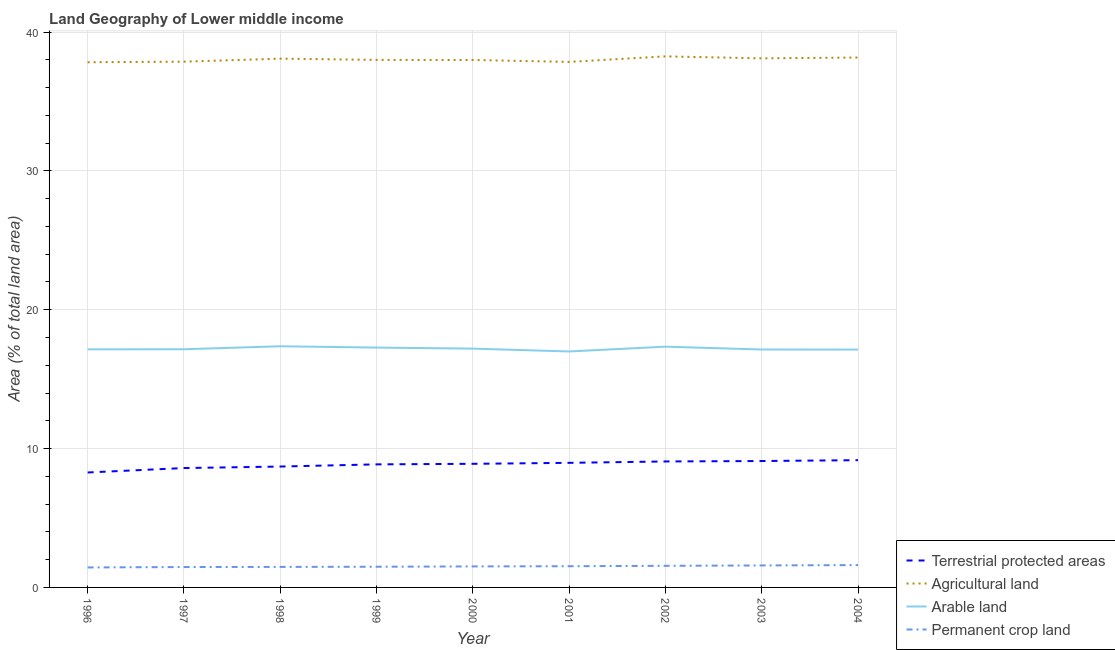Does the line corresponding to percentage of land under terrestrial protection intersect with the line corresponding to percentage of area under agricultural land?
Your response must be concise. No. What is the percentage of area under arable land in 1997?
Give a very brief answer. 17.15. Across all years, what is the maximum percentage of area under arable land?
Your answer should be compact. 17.37. Across all years, what is the minimum percentage of area under arable land?
Offer a terse response. 16.99. In which year was the percentage of area under agricultural land minimum?
Ensure brevity in your answer.  1996. What is the total percentage of land under terrestrial protection in the graph?
Make the answer very short. 79.66. What is the difference between the percentage of area under agricultural land in 1998 and that in 2004?
Ensure brevity in your answer.  -0.08. What is the difference between the percentage of area under arable land in 2001 and the percentage of land under terrestrial protection in 1996?
Offer a very short reply. 8.71. What is the average percentage of area under permanent crop land per year?
Give a very brief answer. 1.52. In the year 1996, what is the difference between the percentage of area under agricultural land and percentage of area under arable land?
Your answer should be compact. 20.68. What is the ratio of the percentage of land under terrestrial protection in 1996 to that in 2004?
Ensure brevity in your answer.  0.9. What is the difference between the highest and the second highest percentage of area under agricultural land?
Ensure brevity in your answer.  0.08. What is the difference between the highest and the lowest percentage of area under arable land?
Your answer should be very brief. 0.37. Is it the case that in every year, the sum of the percentage of land under terrestrial protection and percentage of area under agricultural land is greater than the percentage of area under arable land?
Ensure brevity in your answer.  Yes. Does the percentage of area under arable land monotonically increase over the years?
Your answer should be very brief. No. Is the percentage of area under agricultural land strictly less than the percentage of area under arable land over the years?
Provide a short and direct response. No. How many years are there in the graph?
Keep it short and to the point. 9. What is the difference between two consecutive major ticks on the Y-axis?
Your response must be concise. 10. Are the values on the major ticks of Y-axis written in scientific E-notation?
Provide a succinct answer. No. Does the graph contain grids?
Offer a very short reply. Yes. What is the title of the graph?
Offer a very short reply. Land Geography of Lower middle income. What is the label or title of the Y-axis?
Your answer should be very brief. Area (% of total land area). What is the Area (% of total land area) in Terrestrial protected areas in 1996?
Ensure brevity in your answer.  8.28. What is the Area (% of total land area) in Agricultural land in 1996?
Give a very brief answer. 37.82. What is the Area (% of total land area) in Arable land in 1996?
Your response must be concise. 17.15. What is the Area (% of total land area) in Permanent crop land in 1996?
Offer a terse response. 1.44. What is the Area (% of total land area) of Terrestrial protected areas in 1997?
Ensure brevity in your answer.  8.6. What is the Area (% of total land area) of Agricultural land in 1997?
Ensure brevity in your answer.  37.86. What is the Area (% of total land area) of Arable land in 1997?
Offer a very short reply. 17.15. What is the Area (% of total land area) in Permanent crop land in 1997?
Ensure brevity in your answer.  1.47. What is the Area (% of total land area) in Terrestrial protected areas in 1998?
Your response must be concise. 8.71. What is the Area (% of total land area) in Agricultural land in 1998?
Provide a short and direct response. 38.08. What is the Area (% of total land area) of Arable land in 1998?
Provide a succinct answer. 17.37. What is the Area (% of total land area) in Permanent crop land in 1998?
Offer a terse response. 1.48. What is the Area (% of total land area) in Terrestrial protected areas in 1999?
Provide a succinct answer. 8.86. What is the Area (% of total land area) of Agricultural land in 1999?
Your answer should be very brief. 37.99. What is the Area (% of total land area) in Arable land in 1999?
Make the answer very short. 17.27. What is the Area (% of total land area) in Permanent crop land in 1999?
Offer a terse response. 1.49. What is the Area (% of total land area) in Terrestrial protected areas in 2000?
Offer a terse response. 8.9. What is the Area (% of total land area) in Agricultural land in 2000?
Your response must be concise. 37.98. What is the Area (% of total land area) of Arable land in 2000?
Provide a short and direct response. 17.2. What is the Area (% of total land area) of Permanent crop land in 2000?
Provide a short and direct response. 1.51. What is the Area (% of total land area) in Terrestrial protected areas in 2001?
Your answer should be very brief. 8.97. What is the Area (% of total land area) of Agricultural land in 2001?
Ensure brevity in your answer.  37.85. What is the Area (% of total land area) in Arable land in 2001?
Offer a terse response. 16.99. What is the Area (% of total land area) in Permanent crop land in 2001?
Provide a short and direct response. 1.53. What is the Area (% of total land area) of Terrestrial protected areas in 2002?
Provide a succinct answer. 9.07. What is the Area (% of total land area) in Agricultural land in 2002?
Provide a short and direct response. 38.24. What is the Area (% of total land area) of Arable land in 2002?
Offer a very short reply. 17.34. What is the Area (% of total land area) of Permanent crop land in 2002?
Your answer should be very brief. 1.56. What is the Area (% of total land area) in Terrestrial protected areas in 2003?
Provide a short and direct response. 9.1. What is the Area (% of total land area) of Agricultural land in 2003?
Offer a terse response. 38.1. What is the Area (% of total land area) of Arable land in 2003?
Provide a short and direct response. 17.13. What is the Area (% of total land area) in Permanent crop land in 2003?
Offer a very short reply. 1.58. What is the Area (% of total land area) of Terrestrial protected areas in 2004?
Offer a terse response. 9.16. What is the Area (% of total land area) of Agricultural land in 2004?
Your answer should be compact. 38.16. What is the Area (% of total land area) in Arable land in 2004?
Offer a terse response. 17.13. What is the Area (% of total land area) in Permanent crop land in 2004?
Provide a short and direct response. 1.61. Across all years, what is the maximum Area (% of total land area) in Terrestrial protected areas?
Give a very brief answer. 9.16. Across all years, what is the maximum Area (% of total land area) of Agricultural land?
Give a very brief answer. 38.24. Across all years, what is the maximum Area (% of total land area) in Arable land?
Offer a very short reply. 17.37. Across all years, what is the maximum Area (% of total land area) in Permanent crop land?
Your response must be concise. 1.61. Across all years, what is the minimum Area (% of total land area) of Terrestrial protected areas?
Ensure brevity in your answer.  8.28. Across all years, what is the minimum Area (% of total land area) in Agricultural land?
Offer a very short reply. 37.82. Across all years, what is the minimum Area (% of total land area) of Arable land?
Your response must be concise. 16.99. Across all years, what is the minimum Area (% of total land area) of Permanent crop land?
Your answer should be compact. 1.44. What is the total Area (% of total land area) in Terrestrial protected areas in the graph?
Provide a succinct answer. 79.66. What is the total Area (% of total land area) of Agricultural land in the graph?
Offer a very short reply. 342.1. What is the total Area (% of total land area) of Arable land in the graph?
Ensure brevity in your answer.  154.73. What is the total Area (% of total land area) in Permanent crop land in the graph?
Offer a very short reply. 13.66. What is the difference between the Area (% of total land area) of Terrestrial protected areas in 1996 and that in 1997?
Provide a succinct answer. -0.32. What is the difference between the Area (% of total land area) of Agricultural land in 1996 and that in 1997?
Give a very brief answer. -0.04. What is the difference between the Area (% of total land area) in Arable land in 1996 and that in 1997?
Keep it short and to the point. -0.01. What is the difference between the Area (% of total land area) of Permanent crop land in 1996 and that in 1997?
Offer a very short reply. -0.03. What is the difference between the Area (% of total land area) of Terrestrial protected areas in 1996 and that in 1998?
Provide a short and direct response. -0.43. What is the difference between the Area (% of total land area) of Agricultural land in 1996 and that in 1998?
Ensure brevity in your answer.  -0.26. What is the difference between the Area (% of total land area) of Arable land in 1996 and that in 1998?
Give a very brief answer. -0.22. What is the difference between the Area (% of total land area) of Permanent crop land in 1996 and that in 1998?
Your response must be concise. -0.04. What is the difference between the Area (% of total land area) in Terrestrial protected areas in 1996 and that in 1999?
Provide a succinct answer. -0.58. What is the difference between the Area (% of total land area) of Agricultural land in 1996 and that in 1999?
Keep it short and to the point. -0.17. What is the difference between the Area (% of total land area) in Arable land in 1996 and that in 1999?
Your answer should be very brief. -0.13. What is the difference between the Area (% of total land area) in Permanent crop land in 1996 and that in 1999?
Make the answer very short. -0.05. What is the difference between the Area (% of total land area) in Terrestrial protected areas in 1996 and that in 2000?
Your response must be concise. -0.62. What is the difference between the Area (% of total land area) of Agricultural land in 1996 and that in 2000?
Your response must be concise. -0.16. What is the difference between the Area (% of total land area) of Arable land in 1996 and that in 2000?
Your response must be concise. -0.05. What is the difference between the Area (% of total land area) of Permanent crop land in 1996 and that in 2000?
Your response must be concise. -0.07. What is the difference between the Area (% of total land area) in Terrestrial protected areas in 1996 and that in 2001?
Your answer should be very brief. -0.69. What is the difference between the Area (% of total land area) of Agricultural land in 1996 and that in 2001?
Your response must be concise. -0.03. What is the difference between the Area (% of total land area) of Arable land in 1996 and that in 2001?
Your answer should be very brief. 0.15. What is the difference between the Area (% of total land area) in Permanent crop land in 1996 and that in 2001?
Keep it short and to the point. -0.09. What is the difference between the Area (% of total land area) of Terrestrial protected areas in 1996 and that in 2002?
Your answer should be compact. -0.79. What is the difference between the Area (% of total land area) in Agricultural land in 1996 and that in 2002?
Keep it short and to the point. -0.42. What is the difference between the Area (% of total land area) in Arable land in 1996 and that in 2002?
Keep it short and to the point. -0.19. What is the difference between the Area (% of total land area) of Permanent crop land in 1996 and that in 2002?
Offer a very short reply. -0.12. What is the difference between the Area (% of total land area) in Terrestrial protected areas in 1996 and that in 2003?
Offer a very short reply. -0.82. What is the difference between the Area (% of total land area) in Agricultural land in 1996 and that in 2003?
Your answer should be very brief. -0.28. What is the difference between the Area (% of total land area) of Arable land in 1996 and that in 2003?
Keep it short and to the point. 0.01. What is the difference between the Area (% of total land area) of Permanent crop land in 1996 and that in 2003?
Provide a succinct answer. -0.14. What is the difference between the Area (% of total land area) in Terrestrial protected areas in 1996 and that in 2004?
Offer a terse response. -0.89. What is the difference between the Area (% of total land area) in Agricultural land in 1996 and that in 2004?
Your response must be concise. -0.34. What is the difference between the Area (% of total land area) of Arable land in 1996 and that in 2004?
Offer a terse response. 0.02. What is the difference between the Area (% of total land area) in Permanent crop land in 1996 and that in 2004?
Provide a short and direct response. -0.17. What is the difference between the Area (% of total land area) of Terrestrial protected areas in 1997 and that in 1998?
Give a very brief answer. -0.11. What is the difference between the Area (% of total land area) of Agricultural land in 1997 and that in 1998?
Provide a short and direct response. -0.22. What is the difference between the Area (% of total land area) of Arable land in 1997 and that in 1998?
Your response must be concise. -0.21. What is the difference between the Area (% of total land area) in Permanent crop land in 1997 and that in 1998?
Make the answer very short. -0.01. What is the difference between the Area (% of total land area) of Terrestrial protected areas in 1997 and that in 1999?
Provide a short and direct response. -0.27. What is the difference between the Area (% of total land area) of Agricultural land in 1997 and that in 1999?
Give a very brief answer. -0.13. What is the difference between the Area (% of total land area) in Arable land in 1997 and that in 1999?
Offer a very short reply. -0.12. What is the difference between the Area (% of total land area) of Permanent crop land in 1997 and that in 1999?
Make the answer very short. -0.02. What is the difference between the Area (% of total land area) of Terrestrial protected areas in 1997 and that in 2000?
Your response must be concise. -0.3. What is the difference between the Area (% of total land area) of Agricultural land in 1997 and that in 2000?
Your response must be concise. -0.12. What is the difference between the Area (% of total land area) of Arable land in 1997 and that in 2000?
Offer a very short reply. -0.04. What is the difference between the Area (% of total land area) of Permanent crop land in 1997 and that in 2000?
Your response must be concise. -0.04. What is the difference between the Area (% of total land area) of Terrestrial protected areas in 1997 and that in 2001?
Offer a terse response. -0.38. What is the difference between the Area (% of total land area) of Agricultural land in 1997 and that in 2001?
Your answer should be very brief. 0.02. What is the difference between the Area (% of total land area) in Arable land in 1997 and that in 2001?
Make the answer very short. 0.16. What is the difference between the Area (% of total land area) in Permanent crop land in 1997 and that in 2001?
Make the answer very short. -0.06. What is the difference between the Area (% of total land area) of Terrestrial protected areas in 1997 and that in 2002?
Your response must be concise. -0.47. What is the difference between the Area (% of total land area) of Agricultural land in 1997 and that in 2002?
Give a very brief answer. -0.38. What is the difference between the Area (% of total land area) of Arable land in 1997 and that in 2002?
Your response must be concise. -0.19. What is the difference between the Area (% of total land area) in Permanent crop land in 1997 and that in 2002?
Make the answer very short. -0.09. What is the difference between the Area (% of total land area) of Terrestrial protected areas in 1997 and that in 2003?
Your response must be concise. -0.51. What is the difference between the Area (% of total land area) in Agricultural land in 1997 and that in 2003?
Offer a terse response. -0.24. What is the difference between the Area (% of total land area) in Arable land in 1997 and that in 2003?
Offer a terse response. 0.02. What is the difference between the Area (% of total land area) of Permanent crop land in 1997 and that in 2003?
Offer a very short reply. -0.11. What is the difference between the Area (% of total land area) of Terrestrial protected areas in 1997 and that in 2004?
Provide a short and direct response. -0.57. What is the difference between the Area (% of total land area) in Agricultural land in 1997 and that in 2004?
Keep it short and to the point. -0.3. What is the difference between the Area (% of total land area) of Arable land in 1997 and that in 2004?
Make the answer very short. 0.02. What is the difference between the Area (% of total land area) in Permanent crop land in 1997 and that in 2004?
Provide a short and direct response. -0.14. What is the difference between the Area (% of total land area) of Terrestrial protected areas in 1998 and that in 1999?
Offer a terse response. -0.16. What is the difference between the Area (% of total land area) of Agricultural land in 1998 and that in 1999?
Your response must be concise. 0.09. What is the difference between the Area (% of total land area) in Arable land in 1998 and that in 1999?
Ensure brevity in your answer.  0.09. What is the difference between the Area (% of total land area) in Permanent crop land in 1998 and that in 1999?
Give a very brief answer. -0.01. What is the difference between the Area (% of total land area) of Terrestrial protected areas in 1998 and that in 2000?
Give a very brief answer. -0.2. What is the difference between the Area (% of total land area) in Agricultural land in 1998 and that in 2000?
Make the answer very short. 0.1. What is the difference between the Area (% of total land area) of Arable land in 1998 and that in 2000?
Your answer should be compact. 0.17. What is the difference between the Area (% of total land area) of Permanent crop land in 1998 and that in 2000?
Give a very brief answer. -0.04. What is the difference between the Area (% of total land area) of Terrestrial protected areas in 1998 and that in 2001?
Your answer should be compact. -0.27. What is the difference between the Area (% of total land area) of Agricultural land in 1998 and that in 2001?
Keep it short and to the point. 0.23. What is the difference between the Area (% of total land area) in Arable land in 1998 and that in 2001?
Give a very brief answer. 0.37. What is the difference between the Area (% of total land area) of Permanent crop land in 1998 and that in 2001?
Offer a very short reply. -0.05. What is the difference between the Area (% of total land area) in Terrestrial protected areas in 1998 and that in 2002?
Give a very brief answer. -0.37. What is the difference between the Area (% of total land area) in Agricultural land in 1998 and that in 2002?
Your response must be concise. -0.16. What is the difference between the Area (% of total land area) of Arable land in 1998 and that in 2002?
Ensure brevity in your answer.  0.03. What is the difference between the Area (% of total land area) in Permanent crop land in 1998 and that in 2002?
Offer a very short reply. -0.08. What is the difference between the Area (% of total land area) in Terrestrial protected areas in 1998 and that in 2003?
Keep it short and to the point. -0.4. What is the difference between the Area (% of total land area) of Agricultural land in 1998 and that in 2003?
Ensure brevity in your answer.  -0.02. What is the difference between the Area (% of total land area) of Arable land in 1998 and that in 2003?
Provide a short and direct response. 0.23. What is the difference between the Area (% of total land area) in Permanent crop land in 1998 and that in 2003?
Your response must be concise. -0.1. What is the difference between the Area (% of total land area) in Terrestrial protected areas in 1998 and that in 2004?
Your response must be concise. -0.46. What is the difference between the Area (% of total land area) of Agricultural land in 1998 and that in 2004?
Give a very brief answer. -0.08. What is the difference between the Area (% of total land area) in Arable land in 1998 and that in 2004?
Provide a succinct answer. 0.24. What is the difference between the Area (% of total land area) in Permanent crop land in 1998 and that in 2004?
Offer a terse response. -0.13. What is the difference between the Area (% of total land area) of Terrestrial protected areas in 1999 and that in 2000?
Offer a terse response. -0.04. What is the difference between the Area (% of total land area) of Agricultural land in 1999 and that in 2000?
Ensure brevity in your answer.  0.01. What is the difference between the Area (% of total land area) in Arable land in 1999 and that in 2000?
Your response must be concise. 0.08. What is the difference between the Area (% of total land area) in Permanent crop land in 1999 and that in 2000?
Keep it short and to the point. -0.02. What is the difference between the Area (% of total land area) in Terrestrial protected areas in 1999 and that in 2001?
Offer a terse response. -0.11. What is the difference between the Area (% of total land area) of Agricultural land in 1999 and that in 2001?
Make the answer very short. 0.14. What is the difference between the Area (% of total land area) of Arable land in 1999 and that in 2001?
Give a very brief answer. 0.28. What is the difference between the Area (% of total land area) in Permanent crop land in 1999 and that in 2001?
Keep it short and to the point. -0.04. What is the difference between the Area (% of total land area) in Terrestrial protected areas in 1999 and that in 2002?
Give a very brief answer. -0.21. What is the difference between the Area (% of total land area) in Agricultural land in 1999 and that in 2002?
Keep it short and to the point. -0.25. What is the difference between the Area (% of total land area) of Arable land in 1999 and that in 2002?
Your response must be concise. -0.06. What is the difference between the Area (% of total land area) in Permanent crop land in 1999 and that in 2002?
Offer a terse response. -0.07. What is the difference between the Area (% of total land area) in Terrestrial protected areas in 1999 and that in 2003?
Ensure brevity in your answer.  -0.24. What is the difference between the Area (% of total land area) in Agricultural land in 1999 and that in 2003?
Provide a short and direct response. -0.11. What is the difference between the Area (% of total land area) in Arable land in 1999 and that in 2003?
Give a very brief answer. 0.14. What is the difference between the Area (% of total land area) of Permanent crop land in 1999 and that in 2003?
Your answer should be compact. -0.09. What is the difference between the Area (% of total land area) of Terrestrial protected areas in 1999 and that in 2004?
Give a very brief answer. -0.3. What is the difference between the Area (% of total land area) in Agricultural land in 1999 and that in 2004?
Your answer should be compact. -0.17. What is the difference between the Area (% of total land area) in Arable land in 1999 and that in 2004?
Your answer should be very brief. 0.15. What is the difference between the Area (% of total land area) in Permanent crop land in 1999 and that in 2004?
Make the answer very short. -0.12. What is the difference between the Area (% of total land area) in Terrestrial protected areas in 2000 and that in 2001?
Offer a terse response. -0.07. What is the difference between the Area (% of total land area) in Agricultural land in 2000 and that in 2001?
Make the answer very short. 0.14. What is the difference between the Area (% of total land area) in Arable land in 2000 and that in 2001?
Offer a very short reply. 0.2. What is the difference between the Area (% of total land area) in Permanent crop land in 2000 and that in 2001?
Provide a short and direct response. -0.01. What is the difference between the Area (% of total land area) in Terrestrial protected areas in 2000 and that in 2002?
Provide a succinct answer. -0.17. What is the difference between the Area (% of total land area) of Agricultural land in 2000 and that in 2002?
Give a very brief answer. -0.26. What is the difference between the Area (% of total land area) in Arable land in 2000 and that in 2002?
Keep it short and to the point. -0.14. What is the difference between the Area (% of total land area) of Permanent crop land in 2000 and that in 2002?
Provide a short and direct response. -0.04. What is the difference between the Area (% of total land area) in Terrestrial protected areas in 2000 and that in 2003?
Ensure brevity in your answer.  -0.2. What is the difference between the Area (% of total land area) of Agricultural land in 2000 and that in 2003?
Offer a very short reply. -0.12. What is the difference between the Area (% of total land area) of Arable land in 2000 and that in 2003?
Ensure brevity in your answer.  0.06. What is the difference between the Area (% of total land area) in Permanent crop land in 2000 and that in 2003?
Make the answer very short. -0.07. What is the difference between the Area (% of total land area) in Terrestrial protected areas in 2000 and that in 2004?
Give a very brief answer. -0.26. What is the difference between the Area (% of total land area) in Agricultural land in 2000 and that in 2004?
Give a very brief answer. -0.18. What is the difference between the Area (% of total land area) of Arable land in 2000 and that in 2004?
Provide a succinct answer. 0.07. What is the difference between the Area (% of total land area) in Permanent crop land in 2000 and that in 2004?
Your response must be concise. -0.1. What is the difference between the Area (% of total land area) of Terrestrial protected areas in 2001 and that in 2002?
Give a very brief answer. -0.1. What is the difference between the Area (% of total land area) of Agricultural land in 2001 and that in 2002?
Offer a very short reply. -0.4. What is the difference between the Area (% of total land area) in Arable land in 2001 and that in 2002?
Your answer should be very brief. -0.35. What is the difference between the Area (% of total land area) of Permanent crop land in 2001 and that in 2002?
Give a very brief answer. -0.03. What is the difference between the Area (% of total land area) in Terrestrial protected areas in 2001 and that in 2003?
Your answer should be very brief. -0.13. What is the difference between the Area (% of total land area) of Agricultural land in 2001 and that in 2003?
Your answer should be compact. -0.25. What is the difference between the Area (% of total land area) of Arable land in 2001 and that in 2003?
Provide a short and direct response. -0.14. What is the difference between the Area (% of total land area) of Permanent crop land in 2001 and that in 2003?
Make the answer very short. -0.06. What is the difference between the Area (% of total land area) of Terrestrial protected areas in 2001 and that in 2004?
Offer a very short reply. -0.19. What is the difference between the Area (% of total land area) in Agricultural land in 2001 and that in 2004?
Ensure brevity in your answer.  -0.31. What is the difference between the Area (% of total land area) in Arable land in 2001 and that in 2004?
Your response must be concise. -0.14. What is the difference between the Area (% of total land area) of Permanent crop land in 2001 and that in 2004?
Offer a very short reply. -0.08. What is the difference between the Area (% of total land area) of Terrestrial protected areas in 2002 and that in 2003?
Provide a succinct answer. -0.03. What is the difference between the Area (% of total land area) of Agricultural land in 2002 and that in 2003?
Offer a very short reply. 0.14. What is the difference between the Area (% of total land area) of Arable land in 2002 and that in 2003?
Offer a terse response. 0.21. What is the difference between the Area (% of total land area) in Permanent crop land in 2002 and that in 2003?
Make the answer very short. -0.03. What is the difference between the Area (% of total land area) in Terrestrial protected areas in 2002 and that in 2004?
Offer a very short reply. -0.09. What is the difference between the Area (% of total land area) of Agricultural land in 2002 and that in 2004?
Give a very brief answer. 0.08. What is the difference between the Area (% of total land area) of Arable land in 2002 and that in 2004?
Keep it short and to the point. 0.21. What is the difference between the Area (% of total land area) of Permanent crop land in 2002 and that in 2004?
Ensure brevity in your answer.  -0.05. What is the difference between the Area (% of total land area) in Terrestrial protected areas in 2003 and that in 2004?
Offer a very short reply. -0.06. What is the difference between the Area (% of total land area) of Agricultural land in 2003 and that in 2004?
Ensure brevity in your answer.  -0.06. What is the difference between the Area (% of total land area) of Arable land in 2003 and that in 2004?
Your response must be concise. 0. What is the difference between the Area (% of total land area) in Permanent crop land in 2003 and that in 2004?
Your answer should be compact. -0.03. What is the difference between the Area (% of total land area) in Terrestrial protected areas in 1996 and the Area (% of total land area) in Agricultural land in 1997?
Provide a short and direct response. -29.59. What is the difference between the Area (% of total land area) of Terrestrial protected areas in 1996 and the Area (% of total land area) of Arable land in 1997?
Your response must be concise. -8.88. What is the difference between the Area (% of total land area) of Terrestrial protected areas in 1996 and the Area (% of total land area) of Permanent crop land in 1997?
Provide a succinct answer. 6.81. What is the difference between the Area (% of total land area) of Agricultural land in 1996 and the Area (% of total land area) of Arable land in 1997?
Keep it short and to the point. 20.67. What is the difference between the Area (% of total land area) in Agricultural land in 1996 and the Area (% of total land area) in Permanent crop land in 1997?
Make the answer very short. 36.35. What is the difference between the Area (% of total land area) of Arable land in 1996 and the Area (% of total land area) of Permanent crop land in 1997?
Offer a terse response. 15.68. What is the difference between the Area (% of total land area) of Terrestrial protected areas in 1996 and the Area (% of total land area) of Agricultural land in 1998?
Make the answer very short. -29.8. What is the difference between the Area (% of total land area) of Terrestrial protected areas in 1996 and the Area (% of total land area) of Arable land in 1998?
Provide a succinct answer. -9.09. What is the difference between the Area (% of total land area) of Terrestrial protected areas in 1996 and the Area (% of total land area) of Permanent crop land in 1998?
Give a very brief answer. 6.8. What is the difference between the Area (% of total land area) in Agricultural land in 1996 and the Area (% of total land area) in Arable land in 1998?
Provide a short and direct response. 20.45. What is the difference between the Area (% of total land area) in Agricultural land in 1996 and the Area (% of total land area) in Permanent crop land in 1998?
Make the answer very short. 36.34. What is the difference between the Area (% of total land area) of Arable land in 1996 and the Area (% of total land area) of Permanent crop land in 1998?
Provide a succinct answer. 15.67. What is the difference between the Area (% of total land area) in Terrestrial protected areas in 1996 and the Area (% of total land area) in Agricultural land in 1999?
Your answer should be compact. -29.71. What is the difference between the Area (% of total land area) in Terrestrial protected areas in 1996 and the Area (% of total land area) in Arable land in 1999?
Offer a very short reply. -9. What is the difference between the Area (% of total land area) in Terrestrial protected areas in 1996 and the Area (% of total land area) in Permanent crop land in 1999?
Your answer should be very brief. 6.79. What is the difference between the Area (% of total land area) of Agricultural land in 1996 and the Area (% of total land area) of Arable land in 1999?
Provide a short and direct response. 20.55. What is the difference between the Area (% of total land area) in Agricultural land in 1996 and the Area (% of total land area) in Permanent crop land in 1999?
Provide a succinct answer. 36.33. What is the difference between the Area (% of total land area) of Arable land in 1996 and the Area (% of total land area) of Permanent crop land in 1999?
Offer a very short reply. 15.66. What is the difference between the Area (% of total land area) in Terrestrial protected areas in 1996 and the Area (% of total land area) in Agricultural land in 2000?
Give a very brief answer. -29.71. What is the difference between the Area (% of total land area) of Terrestrial protected areas in 1996 and the Area (% of total land area) of Arable land in 2000?
Give a very brief answer. -8.92. What is the difference between the Area (% of total land area) of Terrestrial protected areas in 1996 and the Area (% of total land area) of Permanent crop land in 2000?
Your answer should be very brief. 6.76. What is the difference between the Area (% of total land area) of Agricultural land in 1996 and the Area (% of total land area) of Arable land in 2000?
Your answer should be very brief. 20.62. What is the difference between the Area (% of total land area) in Agricultural land in 1996 and the Area (% of total land area) in Permanent crop land in 2000?
Give a very brief answer. 36.31. What is the difference between the Area (% of total land area) of Arable land in 1996 and the Area (% of total land area) of Permanent crop land in 2000?
Your response must be concise. 15.63. What is the difference between the Area (% of total land area) of Terrestrial protected areas in 1996 and the Area (% of total land area) of Agricultural land in 2001?
Ensure brevity in your answer.  -29.57. What is the difference between the Area (% of total land area) in Terrestrial protected areas in 1996 and the Area (% of total land area) in Arable land in 2001?
Provide a short and direct response. -8.71. What is the difference between the Area (% of total land area) in Terrestrial protected areas in 1996 and the Area (% of total land area) in Permanent crop land in 2001?
Ensure brevity in your answer.  6.75. What is the difference between the Area (% of total land area) of Agricultural land in 1996 and the Area (% of total land area) of Arable land in 2001?
Your response must be concise. 20.83. What is the difference between the Area (% of total land area) of Agricultural land in 1996 and the Area (% of total land area) of Permanent crop land in 2001?
Your response must be concise. 36.3. What is the difference between the Area (% of total land area) of Arable land in 1996 and the Area (% of total land area) of Permanent crop land in 2001?
Your answer should be compact. 15.62. What is the difference between the Area (% of total land area) in Terrestrial protected areas in 1996 and the Area (% of total land area) in Agricultural land in 2002?
Provide a short and direct response. -29.97. What is the difference between the Area (% of total land area) of Terrestrial protected areas in 1996 and the Area (% of total land area) of Arable land in 2002?
Offer a terse response. -9.06. What is the difference between the Area (% of total land area) in Terrestrial protected areas in 1996 and the Area (% of total land area) in Permanent crop land in 2002?
Make the answer very short. 6.72. What is the difference between the Area (% of total land area) of Agricultural land in 1996 and the Area (% of total land area) of Arable land in 2002?
Your response must be concise. 20.48. What is the difference between the Area (% of total land area) in Agricultural land in 1996 and the Area (% of total land area) in Permanent crop land in 2002?
Your response must be concise. 36.27. What is the difference between the Area (% of total land area) in Arable land in 1996 and the Area (% of total land area) in Permanent crop land in 2002?
Your answer should be compact. 15.59. What is the difference between the Area (% of total land area) in Terrestrial protected areas in 1996 and the Area (% of total land area) in Agricultural land in 2003?
Give a very brief answer. -29.82. What is the difference between the Area (% of total land area) in Terrestrial protected areas in 1996 and the Area (% of total land area) in Arable land in 2003?
Your answer should be very brief. -8.86. What is the difference between the Area (% of total land area) in Terrestrial protected areas in 1996 and the Area (% of total land area) in Permanent crop land in 2003?
Your response must be concise. 6.7. What is the difference between the Area (% of total land area) of Agricultural land in 1996 and the Area (% of total land area) of Arable land in 2003?
Provide a short and direct response. 20.69. What is the difference between the Area (% of total land area) of Agricultural land in 1996 and the Area (% of total land area) of Permanent crop land in 2003?
Your answer should be compact. 36.24. What is the difference between the Area (% of total land area) in Arable land in 1996 and the Area (% of total land area) in Permanent crop land in 2003?
Ensure brevity in your answer.  15.56. What is the difference between the Area (% of total land area) in Terrestrial protected areas in 1996 and the Area (% of total land area) in Agricultural land in 2004?
Offer a very short reply. -29.88. What is the difference between the Area (% of total land area) of Terrestrial protected areas in 1996 and the Area (% of total land area) of Arable land in 2004?
Your response must be concise. -8.85. What is the difference between the Area (% of total land area) in Terrestrial protected areas in 1996 and the Area (% of total land area) in Permanent crop land in 2004?
Keep it short and to the point. 6.67. What is the difference between the Area (% of total land area) in Agricultural land in 1996 and the Area (% of total land area) in Arable land in 2004?
Offer a terse response. 20.69. What is the difference between the Area (% of total land area) in Agricultural land in 1996 and the Area (% of total land area) in Permanent crop land in 2004?
Offer a terse response. 36.21. What is the difference between the Area (% of total land area) of Arable land in 1996 and the Area (% of total land area) of Permanent crop land in 2004?
Your answer should be very brief. 15.54. What is the difference between the Area (% of total land area) in Terrestrial protected areas in 1997 and the Area (% of total land area) in Agricultural land in 1998?
Your answer should be very brief. -29.48. What is the difference between the Area (% of total land area) of Terrestrial protected areas in 1997 and the Area (% of total land area) of Arable land in 1998?
Ensure brevity in your answer.  -8.77. What is the difference between the Area (% of total land area) of Terrestrial protected areas in 1997 and the Area (% of total land area) of Permanent crop land in 1998?
Keep it short and to the point. 7.12. What is the difference between the Area (% of total land area) of Agricultural land in 1997 and the Area (% of total land area) of Arable land in 1998?
Make the answer very short. 20.5. What is the difference between the Area (% of total land area) in Agricultural land in 1997 and the Area (% of total land area) in Permanent crop land in 1998?
Provide a succinct answer. 36.39. What is the difference between the Area (% of total land area) in Arable land in 1997 and the Area (% of total land area) in Permanent crop land in 1998?
Provide a succinct answer. 15.67. What is the difference between the Area (% of total land area) of Terrestrial protected areas in 1997 and the Area (% of total land area) of Agricultural land in 1999?
Offer a terse response. -29.39. What is the difference between the Area (% of total land area) in Terrestrial protected areas in 1997 and the Area (% of total land area) in Arable land in 1999?
Keep it short and to the point. -8.68. What is the difference between the Area (% of total land area) in Terrestrial protected areas in 1997 and the Area (% of total land area) in Permanent crop land in 1999?
Keep it short and to the point. 7.11. What is the difference between the Area (% of total land area) of Agricultural land in 1997 and the Area (% of total land area) of Arable land in 1999?
Keep it short and to the point. 20.59. What is the difference between the Area (% of total land area) in Agricultural land in 1997 and the Area (% of total land area) in Permanent crop land in 1999?
Your response must be concise. 36.37. What is the difference between the Area (% of total land area) of Arable land in 1997 and the Area (% of total land area) of Permanent crop land in 1999?
Keep it short and to the point. 15.66. What is the difference between the Area (% of total land area) of Terrestrial protected areas in 1997 and the Area (% of total land area) of Agricultural land in 2000?
Your answer should be very brief. -29.39. What is the difference between the Area (% of total land area) of Terrestrial protected areas in 1997 and the Area (% of total land area) of Arable land in 2000?
Your answer should be compact. -8.6. What is the difference between the Area (% of total land area) in Terrestrial protected areas in 1997 and the Area (% of total land area) in Permanent crop land in 2000?
Make the answer very short. 7.08. What is the difference between the Area (% of total land area) in Agricultural land in 1997 and the Area (% of total land area) in Arable land in 2000?
Make the answer very short. 20.67. What is the difference between the Area (% of total land area) in Agricultural land in 1997 and the Area (% of total land area) in Permanent crop land in 2000?
Offer a very short reply. 36.35. What is the difference between the Area (% of total land area) of Arable land in 1997 and the Area (% of total land area) of Permanent crop land in 2000?
Offer a very short reply. 15.64. What is the difference between the Area (% of total land area) in Terrestrial protected areas in 1997 and the Area (% of total land area) in Agricultural land in 2001?
Make the answer very short. -29.25. What is the difference between the Area (% of total land area) of Terrestrial protected areas in 1997 and the Area (% of total land area) of Arable land in 2001?
Keep it short and to the point. -8.4. What is the difference between the Area (% of total land area) in Terrestrial protected areas in 1997 and the Area (% of total land area) in Permanent crop land in 2001?
Offer a very short reply. 7.07. What is the difference between the Area (% of total land area) of Agricultural land in 1997 and the Area (% of total land area) of Arable land in 2001?
Keep it short and to the point. 20.87. What is the difference between the Area (% of total land area) of Agricultural land in 1997 and the Area (% of total land area) of Permanent crop land in 2001?
Offer a terse response. 36.34. What is the difference between the Area (% of total land area) of Arable land in 1997 and the Area (% of total land area) of Permanent crop land in 2001?
Offer a terse response. 15.63. What is the difference between the Area (% of total land area) in Terrestrial protected areas in 1997 and the Area (% of total land area) in Agricultural land in 2002?
Your answer should be very brief. -29.65. What is the difference between the Area (% of total land area) in Terrestrial protected areas in 1997 and the Area (% of total land area) in Arable land in 2002?
Your response must be concise. -8.74. What is the difference between the Area (% of total land area) in Terrestrial protected areas in 1997 and the Area (% of total land area) in Permanent crop land in 2002?
Provide a succinct answer. 7.04. What is the difference between the Area (% of total land area) in Agricultural land in 1997 and the Area (% of total land area) in Arable land in 2002?
Offer a very short reply. 20.53. What is the difference between the Area (% of total land area) in Agricultural land in 1997 and the Area (% of total land area) in Permanent crop land in 2002?
Your answer should be very brief. 36.31. What is the difference between the Area (% of total land area) of Arable land in 1997 and the Area (% of total land area) of Permanent crop land in 2002?
Give a very brief answer. 15.6. What is the difference between the Area (% of total land area) in Terrestrial protected areas in 1997 and the Area (% of total land area) in Agricultural land in 2003?
Provide a short and direct response. -29.51. What is the difference between the Area (% of total land area) in Terrestrial protected areas in 1997 and the Area (% of total land area) in Arable land in 2003?
Your response must be concise. -8.54. What is the difference between the Area (% of total land area) in Terrestrial protected areas in 1997 and the Area (% of total land area) in Permanent crop land in 2003?
Make the answer very short. 7.01. What is the difference between the Area (% of total land area) in Agricultural land in 1997 and the Area (% of total land area) in Arable land in 2003?
Keep it short and to the point. 20.73. What is the difference between the Area (% of total land area) of Agricultural land in 1997 and the Area (% of total land area) of Permanent crop land in 2003?
Provide a short and direct response. 36.28. What is the difference between the Area (% of total land area) in Arable land in 1997 and the Area (% of total land area) in Permanent crop land in 2003?
Your response must be concise. 15.57. What is the difference between the Area (% of total land area) of Terrestrial protected areas in 1997 and the Area (% of total land area) of Agricultural land in 2004?
Make the answer very short. -29.57. What is the difference between the Area (% of total land area) of Terrestrial protected areas in 1997 and the Area (% of total land area) of Arable land in 2004?
Offer a very short reply. -8.53. What is the difference between the Area (% of total land area) in Terrestrial protected areas in 1997 and the Area (% of total land area) in Permanent crop land in 2004?
Give a very brief answer. 6.99. What is the difference between the Area (% of total land area) of Agricultural land in 1997 and the Area (% of total land area) of Arable land in 2004?
Provide a short and direct response. 20.74. What is the difference between the Area (% of total land area) of Agricultural land in 1997 and the Area (% of total land area) of Permanent crop land in 2004?
Give a very brief answer. 36.26. What is the difference between the Area (% of total land area) of Arable land in 1997 and the Area (% of total land area) of Permanent crop land in 2004?
Your answer should be compact. 15.54. What is the difference between the Area (% of total land area) of Terrestrial protected areas in 1998 and the Area (% of total land area) of Agricultural land in 1999?
Your response must be concise. -29.29. What is the difference between the Area (% of total land area) of Terrestrial protected areas in 1998 and the Area (% of total land area) of Arable land in 1999?
Provide a short and direct response. -8.57. What is the difference between the Area (% of total land area) of Terrestrial protected areas in 1998 and the Area (% of total land area) of Permanent crop land in 1999?
Ensure brevity in your answer.  7.22. What is the difference between the Area (% of total land area) of Agricultural land in 1998 and the Area (% of total land area) of Arable land in 1999?
Provide a succinct answer. 20.81. What is the difference between the Area (% of total land area) of Agricultural land in 1998 and the Area (% of total land area) of Permanent crop land in 1999?
Your answer should be very brief. 36.59. What is the difference between the Area (% of total land area) in Arable land in 1998 and the Area (% of total land area) in Permanent crop land in 1999?
Provide a short and direct response. 15.88. What is the difference between the Area (% of total land area) in Terrestrial protected areas in 1998 and the Area (% of total land area) in Agricultural land in 2000?
Make the answer very short. -29.28. What is the difference between the Area (% of total land area) of Terrestrial protected areas in 1998 and the Area (% of total land area) of Arable land in 2000?
Your answer should be very brief. -8.49. What is the difference between the Area (% of total land area) of Terrestrial protected areas in 1998 and the Area (% of total land area) of Permanent crop land in 2000?
Your answer should be very brief. 7.19. What is the difference between the Area (% of total land area) in Agricultural land in 1998 and the Area (% of total land area) in Arable land in 2000?
Give a very brief answer. 20.88. What is the difference between the Area (% of total land area) in Agricultural land in 1998 and the Area (% of total land area) in Permanent crop land in 2000?
Your answer should be very brief. 36.57. What is the difference between the Area (% of total land area) of Arable land in 1998 and the Area (% of total land area) of Permanent crop land in 2000?
Offer a very short reply. 15.85. What is the difference between the Area (% of total land area) of Terrestrial protected areas in 1998 and the Area (% of total land area) of Agricultural land in 2001?
Your response must be concise. -29.14. What is the difference between the Area (% of total land area) of Terrestrial protected areas in 1998 and the Area (% of total land area) of Arable land in 2001?
Offer a very short reply. -8.29. What is the difference between the Area (% of total land area) in Terrestrial protected areas in 1998 and the Area (% of total land area) in Permanent crop land in 2001?
Keep it short and to the point. 7.18. What is the difference between the Area (% of total land area) of Agricultural land in 1998 and the Area (% of total land area) of Arable land in 2001?
Keep it short and to the point. 21.09. What is the difference between the Area (% of total land area) of Agricultural land in 1998 and the Area (% of total land area) of Permanent crop land in 2001?
Make the answer very short. 36.55. What is the difference between the Area (% of total land area) in Arable land in 1998 and the Area (% of total land area) in Permanent crop land in 2001?
Provide a short and direct response. 15.84. What is the difference between the Area (% of total land area) in Terrestrial protected areas in 1998 and the Area (% of total land area) in Agricultural land in 2002?
Provide a succinct answer. -29.54. What is the difference between the Area (% of total land area) of Terrestrial protected areas in 1998 and the Area (% of total land area) of Arable land in 2002?
Ensure brevity in your answer.  -8.63. What is the difference between the Area (% of total land area) in Terrestrial protected areas in 1998 and the Area (% of total land area) in Permanent crop land in 2002?
Provide a succinct answer. 7.15. What is the difference between the Area (% of total land area) of Agricultural land in 1998 and the Area (% of total land area) of Arable land in 2002?
Your answer should be very brief. 20.74. What is the difference between the Area (% of total land area) of Agricultural land in 1998 and the Area (% of total land area) of Permanent crop land in 2002?
Give a very brief answer. 36.52. What is the difference between the Area (% of total land area) of Arable land in 1998 and the Area (% of total land area) of Permanent crop land in 2002?
Provide a succinct answer. 15.81. What is the difference between the Area (% of total land area) of Terrestrial protected areas in 1998 and the Area (% of total land area) of Agricultural land in 2003?
Your answer should be compact. -29.4. What is the difference between the Area (% of total land area) in Terrestrial protected areas in 1998 and the Area (% of total land area) in Arable land in 2003?
Your answer should be very brief. -8.43. What is the difference between the Area (% of total land area) in Terrestrial protected areas in 1998 and the Area (% of total land area) in Permanent crop land in 2003?
Ensure brevity in your answer.  7.12. What is the difference between the Area (% of total land area) of Agricultural land in 1998 and the Area (% of total land area) of Arable land in 2003?
Your answer should be very brief. 20.95. What is the difference between the Area (% of total land area) in Agricultural land in 1998 and the Area (% of total land area) in Permanent crop land in 2003?
Provide a succinct answer. 36.5. What is the difference between the Area (% of total land area) in Arable land in 1998 and the Area (% of total land area) in Permanent crop land in 2003?
Offer a terse response. 15.79. What is the difference between the Area (% of total land area) in Terrestrial protected areas in 1998 and the Area (% of total land area) in Agricultural land in 2004?
Make the answer very short. -29.46. What is the difference between the Area (% of total land area) in Terrestrial protected areas in 1998 and the Area (% of total land area) in Arable land in 2004?
Ensure brevity in your answer.  -8.42. What is the difference between the Area (% of total land area) in Terrestrial protected areas in 1998 and the Area (% of total land area) in Permanent crop land in 2004?
Keep it short and to the point. 7.1. What is the difference between the Area (% of total land area) in Agricultural land in 1998 and the Area (% of total land area) in Arable land in 2004?
Offer a terse response. 20.95. What is the difference between the Area (% of total land area) of Agricultural land in 1998 and the Area (% of total land area) of Permanent crop land in 2004?
Your answer should be compact. 36.47. What is the difference between the Area (% of total land area) of Arable land in 1998 and the Area (% of total land area) of Permanent crop land in 2004?
Give a very brief answer. 15.76. What is the difference between the Area (% of total land area) of Terrestrial protected areas in 1999 and the Area (% of total land area) of Agricultural land in 2000?
Give a very brief answer. -29.12. What is the difference between the Area (% of total land area) of Terrestrial protected areas in 1999 and the Area (% of total land area) of Arable land in 2000?
Provide a succinct answer. -8.34. What is the difference between the Area (% of total land area) in Terrestrial protected areas in 1999 and the Area (% of total land area) in Permanent crop land in 2000?
Your answer should be compact. 7.35. What is the difference between the Area (% of total land area) in Agricultural land in 1999 and the Area (% of total land area) in Arable land in 2000?
Ensure brevity in your answer.  20.79. What is the difference between the Area (% of total land area) in Agricultural land in 1999 and the Area (% of total land area) in Permanent crop land in 2000?
Your answer should be compact. 36.48. What is the difference between the Area (% of total land area) in Arable land in 1999 and the Area (% of total land area) in Permanent crop land in 2000?
Give a very brief answer. 15.76. What is the difference between the Area (% of total land area) of Terrestrial protected areas in 1999 and the Area (% of total land area) of Agricultural land in 2001?
Provide a short and direct response. -28.99. What is the difference between the Area (% of total land area) of Terrestrial protected areas in 1999 and the Area (% of total land area) of Arable land in 2001?
Offer a very short reply. -8.13. What is the difference between the Area (% of total land area) in Terrestrial protected areas in 1999 and the Area (% of total land area) in Permanent crop land in 2001?
Your answer should be compact. 7.34. What is the difference between the Area (% of total land area) in Agricultural land in 1999 and the Area (% of total land area) in Arable land in 2001?
Keep it short and to the point. 21. What is the difference between the Area (% of total land area) in Agricultural land in 1999 and the Area (% of total land area) in Permanent crop land in 2001?
Provide a succinct answer. 36.46. What is the difference between the Area (% of total land area) in Arable land in 1999 and the Area (% of total land area) in Permanent crop land in 2001?
Provide a succinct answer. 15.75. What is the difference between the Area (% of total land area) of Terrestrial protected areas in 1999 and the Area (% of total land area) of Agricultural land in 2002?
Your answer should be very brief. -29.38. What is the difference between the Area (% of total land area) in Terrestrial protected areas in 1999 and the Area (% of total land area) in Arable land in 2002?
Offer a very short reply. -8.48. What is the difference between the Area (% of total land area) in Terrestrial protected areas in 1999 and the Area (% of total land area) in Permanent crop land in 2002?
Provide a succinct answer. 7.31. What is the difference between the Area (% of total land area) in Agricultural land in 1999 and the Area (% of total land area) in Arable land in 2002?
Ensure brevity in your answer.  20.65. What is the difference between the Area (% of total land area) of Agricultural land in 1999 and the Area (% of total land area) of Permanent crop land in 2002?
Provide a succinct answer. 36.44. What is the difference between the Area (% of total land area) in Arable land in 1999 and the Area (% of total land area) in Permanent crop land in 2002?
Your response must be concise. 15.72. What is the difference between the Area (% of total land area) of Terrestrial protected areas in 1999 and the Area (% of total land area) of Agricultural land in 2003?
Provide a short and direct response. -29.24. What is the difference between the Area (% of total land area) of Terrestrial protected areas in 1999 and the Area (% of total land area) of Arable land in 2003?
Keep it short and to the point. -8.27. What is the difference between the Area (% of total land area) in Terrestrial protected areas in 1999 and the Area (% of total land area) in Permanent crop land in 2003?
Ensure brevity in your answer.  7.28. What is the difference between the Area (% of total land area) in Agricultural land in 1999 and the Area (% of total land area) in Arable land in 2003?
Give a very brief answer. 20.86. What is the difference between the Area (% of total land area) in Agricultural land in 1999 and the Area (% of total land area) in Permanent crop land in 2003?
Your answer should be compact. 36.41. What is the difference between the Area (% of total land area) in Arable land in 1999 and the Area (% of total land area) in Permanent crop land in 2003?
Provide a short and direct response. 15.69. What is the difference between the Area (% of total land area) of Terrestrial protected areas in 1999 and the Area (% of total land area) of Agricultural land in 2004?
Give a very brief answer. -29.3. What is the difference between the Area (% of total land area) of Terrestrial protected areas in 1999 and the Area (% of total land area) of Arable land in 2004?
Your response must be concise. -8.27. What is the difference between the Area (% of total land area) of Terrestrial protected areas in 1999 and the Area (% of total land area) of Permanent crop land in 2004?
Ensure brevity in your answer.  7.25. What is the difference between the Area (% of total land area) of Agricultural land in 1999 and the Area (% of total land area) of Arable land in 2004?
Provide a short and direct response. 20.86. What is the difference between the Area (% of total land area) of Agricultural land in 1999 and the Area (% of total land area) of Permanent crop land in 2004?
Provide a succinct answer. 36.38. What is the difference between the Area (% of total land area) of Arable land in 1999 and the Area (% of total land area) of Permanent crop land in 2004?
Offer a terse response. 15.67. What is the difference between the Area (% of total land area) in Terrestrial protected areas in 2000 and the Area (% of total land area) in Agricultural land in 2001?
Provide a succinct answer. -28.95. What is the difference between the Area (% of total land area) in Terrestrial protected areas in 2000 and the Area (% of total land area) in Arable land in 2001?
Your response must be concise. -8.09. What is the difference between the Area (% of total land area) in Terrestrial protected areas in 2000 and the Area (% of total land area) in Permanent crop land in 2001?
Offer a terse response. 7.38. What is the difference between the Area (% of total land area) in Agricultural land in 2000 and the Area (% of total land area) in Arable land in 2001?
Ensure brevity in your answer.  20.99. What is the difference between the Area (% of total land area) in Agricultural land in 2000 and the Area (% of total land area) in Permanent crop land in 2001?
Offer a terse response. 36.46. What is the difference between the Area (% of total land area) of Arable land in 2000 and the Area (% of total land area) of Permanent crop land in 2001?
Provide a short and direct response. 15.67. What is the difference between the Area (% of total land area) in Terrestrial protected areas in 2000 and the Area (% of total land area) in Agricultural land in 2002?
Offer a very short reply. -29.34. What is the difference between the Area (% of total land area) of Terrestrial protected areas in 2000 and the Area (% of total land area) of Arable land in 2002?
Ensure brevity in your answer.  -8.44. What is the difference between the Area (% of total land area) of Terrestrial protected areas in 2000 and the Area (% of total land area) of Permanent crop land in 2002?
Your answer should be very brief. 7.35. What is the difference between the Area (% of total land area) in Agricultural land in 2000 and the Area (% of total land area) in Arable land in 2002?
Your answer should be very brief. 20.65. What is the difference between the Area (% of total land area) of Agricultural land in 2000 and the Area (% of total land area) of Permanent crop land in 2002?
Your answer should be compact. 36.43. What is the difference between the Area (% of total land area) of Arable land in 2000 and the Area (% of total land area) of Permanent crop land in 2002?
Offer a very short reply. 15.64. What is the difference between the Area (% of total land area) in Terrestrial protected areas in 2000 and the Area (% of total land area) in Agricultural land in 2003?
Provide a succinct answer. -29.2. What is the difference between the Area (% of total land area) of Terrestrial protected areas in 2000 and the Area (% of total land area) of Arable land in 2003?
Give a very brief answer. -8.23. What is the difference between the Area (% of total land area) of Terrestrial protected areas in 2000 and the Area (% of total land area) of Permanent crop land in 2003?
Provide a short and direct response. 7.32. What is the difference between the Area (% of total land area) of Agricultural land in 2000 and the Area (% of total land area) of Arable land in 2003?
Your answer should be very brief. 20.85. What is the difference between the Area (% of total land area) of Agricultural land in 2000 and the Area (% of total land area) of Permanent crop land in 2003?
Offer a very short reply. 36.4. What is the difference between the Area (% of total land area) in Arable land in 2000 and the Area (% of total land area) in Permanent crop land in 2003?
Give a very brief answer. 15.62. What is the difference between the Area (% of total land area) of Terrestrial protected areas in 2000 and the Area (% of total land area) of Agricultural land in 2004?
Give a very brief answer. -29.26. What is the difference between the Area (% of total land area) in Terrestrial protected areas in 2000 and the Area (% of total land area) in Arable land in 2004?
Your answer should be very brief. -8.23. What is the difference between the Area (% of total land area) in Terrestrial protected areas in 2000 and the Area (% of total land area) in Permanent crop land in 2004?
Offer a very short reply. 7.29. What is the difference between the Area (% of total land area) in Agricultural land in 2000 and the Area (% of total land area) in Arable land in 2004?
Offer a terse response. 20.86. What is the difference between the Area (% of total land area) of Agricultural land in 2000 and the Area (% of total land area) of Permanent crop land in 2004?
Provide a short and direct response. 36.38. What is the difference between the Area (% of total land area) in Arable land in 2000 and the Area (% of total land area) in Permanent crop land in 2004?
Offer a terse response. 15.59. What is the difference between the Area (% of total land area) in Terrestrial protected areas in 2001 and the Area (% of total land area) in Agricultural land in 2002?
Give a very brief answer. -29.27. What is the difference between the Area (% of total land area) in Terrestrial protected areas in 2001 and the Area (% of total land area) in Arable land in 2002?
Provide a succinct answer. -8.37. What is the difference between the Area (% of total land area) of Terrestrial protected areas in 2001 and the Area (% of total land area) of Permanent crop land in 2002?
Keep it short and to the point. 7.42. What is the difference between the Area (% of total land area) in Agricultural land in 2001 and the Area (% of total land area) in Arable land in 2002?
Keep it short and to the point. 20.51. What is the difference between the Area (% of total land area) in Agricultural land in 2001 and the Area (% of total land area) in Permanent crop land in 2002?
Your answer should be very brief. 36.29. What is the difference between the Area (% of total land area) of Arable land in 2001 and the Area (% of total land area) of Permanent crop land in 2002?
Provide a succinct answer. 15.44. What is the difference between the Area (% of total land area) of Terrestrial protected areas in 2001 and the Area (% of total land area) of Agricultural land in 2003?
Keep it short and to the point. -29.13. What is the difference between the Area (% of total land area) of Terrestrial protected areas in 2001 and the Area (% of total land area) of Arable land in 2003?
Make the answer very short. -8.16. What is the difference between the Area (% of total land area) in Terrestrial protected areas in 2001 and the Area (% of total land area) in Permanent crop land in 2003?
Your answer should be compact. 7.39. What is the difference between the Area (% of total land area) in Agricultural land in 2001 and the Area (% of total land area) in Arable land in 2003?
Offer a very short reply. 20.71. What is the difference between the Area (% of total land area) of Agricultural land in 2001 and the Area (% of total land area) of Permanent crop land in 2003?
Give a very brief answer. 36.27. What is the difference between the Area (% of total land area) in Arable land in 2001 and the Area (% of total land area) in Permanent crop land in 2003?
Your answer should be very brief. 15.41. What is the difference between the Area (% of total land area) of Terrestrial protected areas in 2001 and the Area (% of total land area) of Agricultural land in 2004?
Provide a succinct answer. -29.19. What is the difference between the Area (% of total land area) in Terrestrial protected areas in 2001 and the Area (% of total land area) in Arable land in 2004?
Provide a short and direct response. -8.16. What is the difference between the Area (% of total land area) in Terrestrial protected areas in 2001 and the Area (% of total land area) in Permanent crop land in 2004?
Offer a very short reply. 7.36. What is the difference between the Area (% of total land area) of Agricultural land in 2001 and the Area (% of total land area) of Arable land in 2004?
Offer a very short reply. 20.72. What is the difference between the Area (% of total land area) in Agricultural land in 2001 and the Area (% of total land area) in Permanent crop land in 2004?
Provide a succinct answer. 36.24. What is the difference between the Area (% of total land area) of Arable land in 2001 and the Area (% of total land area) of Permanent crop land in 2004?
Your response must be concise. 15.38. What is the difference between the Area (% of total land area) of Terrestrial protected areas in 2002 and the Area (% of total land area) of Agricultural land in 2003?
Your answer should be very brief. -29.03. What is the difference between the Area (% of total land area) of Terrestrial protected areas in 2002 and the Area (% of total land area) of Arable land in 2003?
Your answer should be very brief. -8.06. What is the difference between the Area (% of total land area) of Terrestrial protected areas in 2002 and the Area (% of total land area) of Permanent crop land in 2003?
Give a very brief answer. 7.49. What is the difference between the Area (% of total land area) of Agricultural land in 2002 and the Area (% of total land area) of Arable land in 2003?
Offer a terse response. 21.11. What is the difference between the Area (% of total land area) in Agricultural land in 2002 and the Area (% of total land area) in Permanent crop land in 2003?
Your answer should be compact. 36.66. What is the difference between the Area (% of total land area) of Arable land in 2002 and the Area (% of total land area) of Permanent crop land in 2003?
Ensure brevity in your answer.  15.76. What is the difference between the Area (% of total land area) of Terrestrial protected areas in 2002 and the Area (% of total land area) of Agricultural land in 2004?
Keep it short and to the point. -29.09. What is the difference between the Area (% of total land area) of Terrestrial protected areas in 2002 and the Area (% of total land area) of Arable land in 2004?
Offer a terse response. -8.06. What is the difference between the Area (% of total land area) of Terrestrial protected areas in 2002 and the Area (% of total land area) of Permanent crop land in 2004?
Offer a very short reply. 7.46. What is the difference between the Area (% of total land area) of Agricultural land in 2002 and the Area (% of total land area) of Arable land in 2004?
Offer a very short reply. 21.12. What is the difference between the Area (% of total land area) of Agricultural land in 2002 and the Area (% of total land area) of Permanent crop land in 2004?
Your answer should be very brief. 36.64. What is the difference between the Area (% of total land area) in Arable land in 2002 and the Area (% of total land area) in Permanent crop land in 2004?
Offer a terse response. 15.73. What is the difference between the Area (% of total land area) in Terrestrial protected areas in 2003 and the Area (% of total land area) in Agricultural land in 2004?
Your answer should be very brief. -29.06. What is the difference between the Area (% of total land area) in Terrestrial protected areas in 2003 and the Area (% of total land area) in Arable land in 2004?
Ensure brevity in your answer.  -8.03. What is the difference between the Area (% of total land area) of Terrestrial protected areas in 2003 and the Area (% of total land area) of Permanent crop land in 2004?
Give a very brief answer. 7.49. What is the difference between the Area (% of total land area) of Agricultural land in 2003 and the Area (% of total land area) of Arable land in 2004?
Keep it short and to the point. 20.97. What is the difference between the Area (% of total land area) in Agricultural land in 2003 and the Area (% of total land area) in Permanent crop land in 2004?
Offer a terse response. 36.49. What is the difference between the Area (% of total land area) of Arable land in 2003 and the Area (% of total land area) of Permanent crop land in 2004?
Your response must be concise. 15.52. What is the average Area (% of total land area) of Terrestrial protected areas per year?
Ensure brevity in your answer.  8.85. What is the average Area (% of total land area) of Agricultural land per year?
Keep it short and to the point. 38.01. What is the average Area (% of total land area) in Arable land per year?
Offer a terse response. 17.19. What is the average Area (% of total land area) of Permanent crop land per year?
Your answer should be very brief. 1.52. In the year 1996, what is the difference between the Area (% of total land area) in Terrestrial protected areas and Area (% of total land area) in Agricultural land?
Provide a succinct answer. -29.54. In the year 1996, what is the difference between the Area (% of total land area) of Terrestrial protected areas and Area (% of total land area) of Arable land?
Offer a very short reply. -8.87. In the year 1996, what is the difference between the Area (% of total land area) in Terrestrial protected areas and Area (% of total land area) in Permanent crop land?
Your answer should be very brief. 6.84. In the year 1996, what is the difference between the Area (% of total land area) in Agricultural land and Area (% of total land area) in Arable land?
Keep it short and to the point. 20.68. In the year 1996, what is the difference between the Area (% of total land area) of Agricultural land and Area (% of total land area) of Permanent crop land?
Your answer should be compact. 36.38. In the year 1996, what is the difference between the Area (% of total land area) in Arable land and Area (% of total land area) in Permanent crop land?
Offer a very short reply. 15.71. In the year 1997, what is the difference between the Area (% of total land area) in Terrestrial protected areas and Area (% of total land area) in Agricultural land?
Provide a short and direct response. -29.27. In the year 1997, what is the difference between the Area (% of total land area) in Terrestrial protected areas and Area (% of total land area) in Arable land?
Offer a very short reply. -8.56. In the year 1997, what is the difference between the Area (% of total land area) in Terrestrial protected areas and Area (% of total land area) in Permanent crop land?
Offer a terse response. 7.13. In the year 1997, what is the difference between the Area (% of total land area) in Agricultural land and Area (% of total land area) in Arable land?
Offer a terse response. 20.71. In the year 1997, what is the difference between the Area (% of total land area) in Agricultural land and Area (% of total land area) in Permanent crop land?
Your answer should be very brief. 36.4. In the year 1997, what is the difference between the Area (% of total land area) in Arable land and Area (% of total land area) in Permanent crop land?
Your response must be concise. 15.68. In the year 1998, what is the difference between the Area (% of total land area) in Terrestrial protected areas and Area (% of total land area) in Agricultural land?
Keep it short and to the point. -29.38. In the year 1998, what is the difference between the Area (% of total land area) in Terrestrial protected areas and Area (% of total land area) in Arable land?
Offer a very short reply. -8.66. In the year 1998, what is the difference between the Area (% of total land area) in Terrestrial protected areas and Area (% of total land area) in Permanent crop land?
Provide a short and direct response. 7.23. In the year 1998, what is the difference between the Area (% of total land area) of Agricultural land and Area (% of total land area) of Arable land?
Your answer should be compact. 20.71. In the year 1998, what is the difference between the Area (% of total land area) of Agricultural land and Area (% of total land area) of Permanent crop land?
Your answer should be compact. 36.6. In the year 1998, what is the difference between the Area (% of total land area) of Arable land and Area (% of total land area) of Permanent crop land?
Offer a terse response. 15.89. In the year 1999, what is the difference between the Area (% of total land area) in Terrestrial protected areas and Area (% of total land area) in Agricultural land?
Ensure brevity in your answer.  -29.13. In the year 1999, what is the difference between the Area (% of total land area) in Terrestrial protected areas and Area (% of total land area) in Arable land?
Give a very brief answer. -8.41. In the year 1999, what is the difference between the Area (% of total land area) in Terrestrial protected areas and Area (% of total land area) in Permanent crop land?
Ensure brevity in your answer.  7.37. In the year 1999, what is the difference between the Area (% of total land area) in Agricultural land and Area (% of total land area) in Arable land?
Keep it short and to the point. 20.72. In the year 1999, what is the difference between the Area (% of total land area) of Agricultural land and Area (% of total land area) of Permanent crop land?
Offer a very short reply. 36.5. In the year 1999, what is the difference between the Area (% of total land area) in Arable land and Area (% of total land area) in Permanent crop land?
Ensure brevity in your answer.  15.78. In the year 2000, what is the difference between the Area (% of total land area) in Terrestrial protected areas and Area (% of total land area) in Agricultural land?
Offer a very short reply. -29.08. In the year 2000, what is the difference between the Area (% of total land area) of Terrestrial protected areas and Area (% of total land area) of Arable land?
Offer a terse response. -8.3. In the year 2000, what is the difference between the Area (% of total land area) of Terrestrial protected areas and Area (% of total land area) of Permanent crop land?
Provide a short and direct response. 7.39. In the year 2000, what is the difference between the Area (% of total land area) in Agricultural land and Area (% of total land area) in Arable land?
Give a very brief answer. 20.79. In the year 2000, what is the difference between the Area (% of total land area) in Agricultural land and Area (% of total land area) in Permanent crop land?
Offer a terse response. 36.47. In the year 2000, what is the difference between the Area (% of total land area) of Arable land and Area (% of total land area) of Permanent crop land?
Offer a very short reply. 15.68. In the year 2001, what is the difference between the Area (% of total land area) of Terrestrial protected areas and Area (% of total land area) of Agricultural land?
Ensure brevity in your answer.  -28.88. In the year 2001, what is the difference between the Area (% of total land area) of Terrestrial protected areas and Area (% of total land area) of Arable land?
Give a very brief answer. -8.02. In the year 2001, what is the difference between the Area (% of total land area) of Terrestrial protected areas and Area (% of total land area) of Permanent crop land?
Offer a very short reply. 7.45. In the year 2001, what is the difference between the Area (% of total land area) of Agricultural land and Area (% of total land area) of Arable land?
Your answer should be very brief. 20.85. In the year 2001, what is the difference between the Area (% of total land area) of Agricultural land and Area (% of total land area) of Permanent crop land?
Provide a short and direct response. 36.32. In the year 2001, what is the difference between the Area (% of total land area) of Arable land and Area (% of total land area) of Permanent crop land?
Your answer should be compact. 15.47. In the year 2002, what is the difference between the Area (% of total land area) in Terrestrial protected areas and Area (% of total land area) in Agricultural land?
Your answer should be compact. -29.17. In the year 2002, what is the difference between the Area (% of total land area) of Terrestrial protected areas and Area (% of total land area) of Arable land?
Your response must be concise. -8.27. In the year 2002, what is the difference between the Area (% of total land area) in Terrestrial protected areas and Area (% of total land area) in Permanent crop land?
Give a very brief answer. 7.52. In the year 2002, what is the difference between the Area (% of total land area) in Agricultural land and Area (% of total land area) in Arable land?
Make the answer very short. 20.91. In the year 2002, what is the difference between the Area (% of total land area) in Agricultural land and Area (% of total land area) in Permanent crop land?
Keep it short and to the point. 36.69. In the year 2002, what is the difference between the Area (% of total land area) of Arable land and Area (% of total land area) of Permanent crop land?
Your answer should be compact. 15.78. In the year 2003, what is the difference between the Area (% of total land area) in Terrestrial protected areas and Area (% of total land area) in Agricultural land?
Your answer should be very brief. -29. In the year 2003, what is the difference between the Area (% of total land area) in Terrestrial protected areas and Area (% of total land area) in Arable land?
Make the answer very short. -8.03. In the year 2003, what is the difference between the Area (% of total land area) in Terrestrial protected areas and Area (% of total land area) in Permanent crop land?
Offer a very short reply. 7.52. In the year 2003, what is the difference between the Area (% of total land area) of Agricultural land and Area (% of total land area) of Arable land?
Provide a succinct answer. 20.97. In the year 2003, what is the difference between the Area (% of total land area) of Agricultural land and Area (% of total land area) of Permanent crop land?
Your answer should be very brief. 36.52. In the year 2003, what is the difference between the Area (% of total land area) in Arable land and Area (% of total land area) in Permanent crop land?
Your answer should be very brief. 15.55. In the year 2004, what is the difference between the Area (% of total land area) in Terrestrial protected areas and Area (% of total land area) in Agricultural land?
Provide a short and direct response. -29. In the year 2004, what is the difference between the Area (% of total land area) of Terrestrial protected areas and Area (% of total land area) of Arable land?
Give a very brief answer. -7.96. In the year 2004, what is the difference between the Area (% of total land area) of Terrestrial protected areas and Area (% of total land area) of Permanent crop land?
Offer a terse response. 7.56. In the year 2004, what is the difference between the Area (% of total land area) of Agricultural land and Area (% of total land area) of Arable land?
Give a very brief answer. 21.03. In the year 2004, what is the difference between the Area (% of total land area) in Agricultural land and Area (% of total land area) in Permanent crop land?
Provide a succinct answer. 36.55. In the year 2004, what is the difference between the Area (% of total land area) in Arable land and Area (% of total land area) in Permanent crop land?
Your response must be concise. 15.52. What is the ratio of the Area (% of total land area) of Terrestrial protected areas in 1996 to that in 1997?
Your answer should be very brief. 0.96. What is the ratio of the Area (% of total land area) in Arable land in 1996 to that in 1997?
Make the answer very short. 1. What is the ratio of the Area (% of total land area) of Permanent crop land in 1996 to that in 1997?
Your answer should be compact. 0.98. What is the ratio of the Area (% of total land area) in Terrestrial protected areas in 1996 to that in 1998?
Offer a terse response. 0.95. What is the ratio of the Area (% of total land area) of Arable land in 1996 to that in 1998?
Your response must be concise. 0.99. What is the ratio of the Area (% of total land area) of Permanent crop land in 1996 to that in 1998?
Provide a short and direct response. 0.97. What is the ratio of the Area (% of total land area) of Terrestrial protected areas in 1996 to that in 1999?
Provide a succinct answer. 0.93. What is the ratio of the Area (% of total land area) in Arable land in 1996 to that in 1999?
Make the answer very short. 0.99. What is the ratio of the Area (% of total land area) of Permanent crop land in 1996 to that in 1999?
Keep it short and to the point. 0.97. What is the ratio of the Area (% of total land area) in Terrestrial protected areas in 1996 to that in 2000?
Your answer should be very brief. 0.93. What is the ratio of the Area (% of total land area) of Agricultural land in 1996 to that in 2000?
Provide a succinct answer. 1. What is the ratio of the Area (% of total land area) of Arable land in 1996 to that in 2000?
Provide a short and direct response. 1. What is the ratio of the Area (% of total land area) in Permanent crop land in 1996 to that in 2000?
Offer a very short reply. 0.95. What is the ratio of the Area (% of total land area) in Terrestrial protected areas in 1996 to that in 2001?
Ensure brevity in your answer.  0.92. What is the ratio of the Area (% of total land area) of Agricultural land in 1996 to that in 2001?
Give a very brief answer. 1. What is the ratio of the Area (% of total land area) of Permanent crop land in 1996 to that in 2001?
Offer a terse response. 0.94. What is the ratio of the Area (% of total land area) of Terrestrial protected areas in 1996 to that in 2002?
Your response must be concise. 0.91. What is the ratio of the Area (% of total land area) of Arable land in 1996 to that in 2002?
Make the answer very short. 0.99. What is the ratio of the Area (% of total land area) of Permanent crop land in 1996 to that in 2002?
Your answer should be compact. 0.92. What is the ratio of the Area (% of total land area) in Terrestrial protected areas in 1996 to that in 2003?
Your answer should be very brief. 0.91. What is the ratio of the Area (% of total land area) of Arable land in 1996 to that in 2003?
Offer a terse response. 1. What is the ratio of the Area (% of total land area) of Permanent crop land in 1996 to that in 2003?
Offer a very short reply. 0.91. What is the ratio of the Area (% of total land area) in Terrestrial protected areas in 1996 to that in 2004?
Offer a very short reply. 0.9. What is the ratio of the Area (% of total land area) of Agricultural land in 1996 to that in 2004?
Your answer should be compact. 0.99. What is the ratio of the Area (% of total land area) in Arable land in 1996 to that in 2004?
Offer a very short reply. 1. What is the ratio of the Area (% of total land area) in Permanent crop land in 1996 to that in 2004?
Your answer should be very brief. 0.89. What is the ratio of the Area (% of total land area) of Terrestrial protected areas in 1997 to that in 1998?
Make the answer very short. 0.99. What is the ratio of the Area (% of total land area) of Arable land in 1997 to that in 1998?
Provide a succinct answer. 0.99. What is the ratio of the Area (% of total land area) in Permanent crop land in 1997 to that in 1998?
Your answer should be very brief. 0.99. What is the ratio of the Area (% of total land area) of Terrestrial protected areas in 1997 to that in 1999?
Your response must be concise. 0.97. What is the ratio of the Area (% of total land area) in Agricultural land in 1997 to that in 1999?
Your answer should be compact. 1. What is the ratio of the Area (% of total land area) of Arable land in 1997 to that in 1999?
Offer a terse response. 0.99. What is the ratio of the Area (% of total land area) in Permanent crop land in 1997 to that in 1999?
Your response must be concise. 0.99. What is the ratio of the Area (% of total land area) of Terrestrial protected areas in 1997 to that in 2000?
Your response must be concise. 0.97. What is the ratio of the Area (% of total land area) in Agricultural land in 1997 to that in 2000?
Your answer should be very brief. 1. What is the ratio of the Area (% of total land area) in Permanent crop land in 1997 to that in 2000?
Your response must be concise. 0.97. What is the ratio of the Area (% of total land area) in Terrestrial protected areas in 1997 to that in 2001?
Offer a very short reply. 0.96. What is the ratio of the Area (% of total land area) in Agricultural land in 1997 to that in 2001?
Provide a short and direct response. 1. What is the ratio of the Area (% of total land area) in Arable land in 1997 to that in 2001?
Offer a very short reply. 1.01. What is the ratio of the Area (% of total land area) of Permanent crop land in 1997 to that in 2001?
Offer a very short reply. 0.96. What is the ratio of the Area (% of total land area) of Terrestrial protected areas in 1997 to that in 2002?
Your answer should be very brief. 0.95. What is the ratio of the Area (% of total land area) of Agricultural land in 1997 to that in 2002?
Make the answer very short. 0.99. What is the ratio of the Area (% of total land area) in Arable land in 1997 to that in 2002?
Offer a very short reply. 0.99. What is the ratio of the Area (% of total land area) in Permanent crop land in 1997 to that in 2002?
Provide a short and direct response. 0.94. What is the ratio of the Area (% of total land area) of Terrestrial protected areas in 1997 to that in 2003?
Offer a very short reply. 0.94. What is the ratio of the Area (% of total land area) of Agricultural land in 1997 to that in 2003?
Your answer should be compact. 0.99. What is the ratio of the Area (% of total land area) in Permanent crop land in 1997 to that in 2003?
Provide a succinct answer. 0.93. What is the ratio of the Area (% of total land area) of Terrestrial protected areas in 1997 to that in 2004?
Your answer should be very brief. 0.94. What is the ratio of the Area (% of total land area) of Agricultural land in 1997 to that in 2004?
Give a very brief answer. 0.99. What is the ratio of the Area (% of total land area) of Terrestrial protected areas in 1998 to that in 1999?
Offer a terse response. 0.98. What is the ratio of the Area (% of total land area) of Agricultural land in 1998 to that in 1999?
Provide a short and direct response. 1. What is the ratio of the Area (% of total land area) in Arable land in 1998 to that in 1999?
Your answer should be compact. 1.01. What is the ratio of the Area (% of total land area) in Permanent crop land in 1998 to that in 1999?
Offer a terse response. 0.99. What is the ratio of the Area (% of total land area) of Terrestrial protected areas in 1998 to that in 2000?
Your answer should be very brief. 0.98. What is the ratio of the Area (% of total land area) in Agricultural land in 1998 to that in 2000?
Give a very brief answer. 1. What is the ratio of the Area (% of total land area) in Arable land in 1998 to that in 2000?
Make the answer very short. 1.01. What is the ratio of the Area (% of total land area) in Permanent crop land in 1998 to that in 2000?
Provide a succinct answer. 0.98. What is the ratio of the Area (% of total land area) of Terrestrial protected areas in 1998 to that in 2001?
Offer a terse response. 0.97. What is the ratio of the Area (% of total land area) of Agricultural land in 1998 to that in 2001?
Keep it short and to the point. 1.01. What is the ratio of the Area (% of total land area) in Arable land in 1998 to that in 2001?
Your response must be concise. 1.02. What is the ratio of the Area (% of total land area) of Permanent crop land in 1998 to that in 2001?
Your response must be concise. 0.97. What is the ratio of the Area (% of total land area) in Terrestrial protected areas in 1998 to that in 2002?
Offer a terse response. 0.96. What is the ratio of the Area (% of total land area) in Permanent crop land in 1998 to that in 2002?
Your answer should be very brief. 0.95. What is the ratio of the Area (% of total land area) in Terrestrial protected areas in 1998 to that in 2003?
Your answer should be very brief. 0.96. What is the ratio of the Area (% of total land area) in Arable land in 1998 to that in 2003?
Ensure brevity in your answer.  1.01. What is the ratio of the Area (% of total land area) in Permanent crop land in 1998 to that in 2003?
Your answer should be compact. 0.93. What is the ratio of the Area (% of total land area) of Terrestrial protected areas in 1998 to that in 2004?
Ensure brevity in your answer.  0.95. What is the ratio of the Area (% of total land area) of Agricultural land in 1998 to that in 2004?
Your answer should be very brief. 1. What is the ratio of the Area (% of total land area) in Arable land in 1998 to that in 2004?
Keep it short and to the point. 1.01. What is the ratio of the Area (% of total land area) in Permanent crop land in 1998 to that in 2004?
Make the answer very short. 0.92. What is the ratio of the Area (% of total land area) of Terrestrial protected areas in 1999 to that in 2000?
Offer a very short reply. 1. What is the ratio of the Area (% of total land area) in Permanent crop land in 1999 to that in 2000?
Your response must be concise. 0.98. What is the ratio of the Area (% of total land area) in Terrestrial protected areas in 1999 to that in 2001?
Offer a very short reply. 0.99. What is the ratio of the Area (% of total land area) in Agricultural land in 1999 to that in 2001?
Your answer should be compact. 1. What is the ratio of the Area (% of total land area) in Arable land in 1999 to that in 2001?
Offer a very short reply. 1.02. What is the ratio of the Area (% of total land area) of Permanent crop land in 1999 to that in 2001?
Make the answer very short. 0.98. What is the ratio of the Area (% of total land area) of Terrestrial protected areas in 1999 to that in 2002?
Keep it short and to the point. 0.98. What is the ratio of the Area (% of total land area) in Permanent crop land in 1999 to that in 2002?
Make the answer very short. 0.96. What is the ratio of the Area (% of total land area) in Terrestrial protected areas in 1999 to that in 2003?
Your answer should be very brief. 0.97. What is the ratio of the Area (% of total land area) of Agricultural land in 1999 to that in 2003?
Your answer should be compact. 1. What is the ratio of the Area (% of total land area) of Arable land in 1999 to that in 2003?
Provide a succinct answer. 1.01. What is the ratio of the Area (% of total land area) in Permanent crop land in 1999 to that in 2003?
Your answer should be very brief. 0.94. What is the ratio of the Area (% of total land area) of Terrestrial protected areas in 1999 to that in 2004?
Provide a short and direct response. 0.97. What is the ratio of the Area (% of total land area) in Agricultural land in 1999 to that in 2004?
Offer a very short reply. 1. What is the ratio of the Area (% of total land area) of Arable land in 1999 to that in 2004?
Offer a very short reply. 1.01. What is the ratio of the Area (% of total land area) in Permanent crop land in 1999 to that in 2004?
Your response must be concise. 0.93. What is the ratio of the Area (% of total land area) in Arable land in 2000 to that in 2001?
Your response must be concise. 1.01. What is the ratio of the Area (% of total land area) in Permanent crop land in 2000 to that in 2001?
Keep it short and to the point. 0.99. What is the ratio of the Area (% of total land area) in Terrestrial protected areas in 2000 to that in 2002?
Offer a terse response. 0.98. What is the ratio of the Area (% of total land area) of Permanent crop land in 2000 to that in 2002?
Give a very brief answer. 0.97. What is the ratio of the Area (% of total land area) of Terrestrial protected areas in 2000 to that in 2003?
Keep it short and to the point. 0.98. What is the ratio of the Area (% of total land area) in Agricultural land in 2000 to that in 2003?
Your answer should be very brief. 1. What is the ratio of the Area (% of total land area) in Permanent crop land in 2000 to that in 2003?
Keep it short and to the point. 0.96. What is the ratio of the Area (% of total land area) in Terrestrial protected areas in 2000 to that in 2004?
Your answer should be very brief. 0.97. What is the ratio of the Area (% of total land area) in Agricultural land in 2000 to that in 2004?
Provide a succinct answer. 1. What is the ratio of the Area (% of total land area) of Permanent crop land in 2000 to that in 2004?
Make the answer very short. 0.94. What is the ratio of the Area (% of total land area) of Arable land in 2001 to that in 2002?
Your answer should be very brief. 0.98. What is the ratio of the Area (% of total land area) in Terrestrial protected areas in 2001 to that in 2003?
Your answer should be compact. 0.99. What is the ratio of the Area (% of total land area) of Arable land in 2001 to that in 2003?
Offer a very short reply. 0.99. What is the ratio of the Area (% of total land area) in Permanent crop land in 2001 to that in 2003?
Keep it short and to the point. 0.96. What is the ratio of the Area (% of total land area) of Terrestrial protected areas in 2001 to that in 2004?
Keep it short and to the point. 0.98. What is the ratio of the Area (% of total land area) in Agricultural land in 2001 to that in 2004?
Your response must be concise. 0.99. What is the ratio of the Area (% of total land area) in Arable land in 2001 to that in 2004?
Keep it short and to the point. 0.99. What is the ratio of the Area (% of total land area) of Permanent crop land in 2001 to that in 2004?
Your answer should be compact. 0.95. What is the ratio of the Area (% of total land area) in Agricultural land in 2002 to that in 2003?
Offer a terse response. 1. What is the ratio of the Area (% of total land area) of Arable land in 2002 to that in 2003?
Offer a terse response. 1.01. What is the ratio of the Area (% of total land area) in Permanent crop land in 2002 to that in 2003?
Provide a short and direct response. 0.98. What is the ratio of the Area (% of total land area) of Agricultural land in 2002 to that in 2004?
Provide a succinct answer. 1. What is the ratio of the Area (% of total land area) in Arable land in 2002 to that in 2004?
Provide a short and direct response. 1.01. What is the ratio of the Area (% of total land area) in Permanent crop land in 2002 to that in 2004?
Provide a succinct answer. 0.97. What is the ratio of the Area (% of total land area) of Terrestrial protected areas in 2003 to that in 2004?
Offer a terse response. 0.99. What is the ratio of the Area (% of total land area) of Agricultural land in 2003 to that in 2004?
Your answer should be compact. 1. What is the ratio of the Area (% of total land area) of Permanent crop land in 2003 to that in 2004?
Your answer should be very brief. 0.98. What is the difference between the highest and the second highest Area (% of total land area) of Terrestrial protected areas?
Make the answer very short. 0.06. What is the difference between the highest and the second highest Area (% of total land area) of Agricultural land?
Provide a succinct answer. 0.08. What is the difference between the highest and the second highest Area (% of total land area) of Arable land?
Offer a terse response. 0.03. What is the difference between the highest and the second highest Area (% of total land area) of Permanent crop land?
Provide a succinct answer. 0.03. What is the difference between the highest and the lowest Area (% of total land area) of Terrestrial protected areas?
Offer a terse response. 0.89. What is the difference between the highest and the lowest Area (% of total land area) in Agricultural land?
Keep it short and to the point. 0.42. What is the difference between the highest and the lowest Area (% of total land area) of Arable land?
Offer a terse response. 0.37. What is the difference between the highest and the lowest Area (% of total land area) of Permanent crop land?
Ensure brevity in your answer.  0.17. 